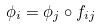Convert formula to latex. <formula><loc_0><loc_0><loc_500><loc_500>\phi _ { i } = \phi _ { j } \circ f _ { i j }</formula> 